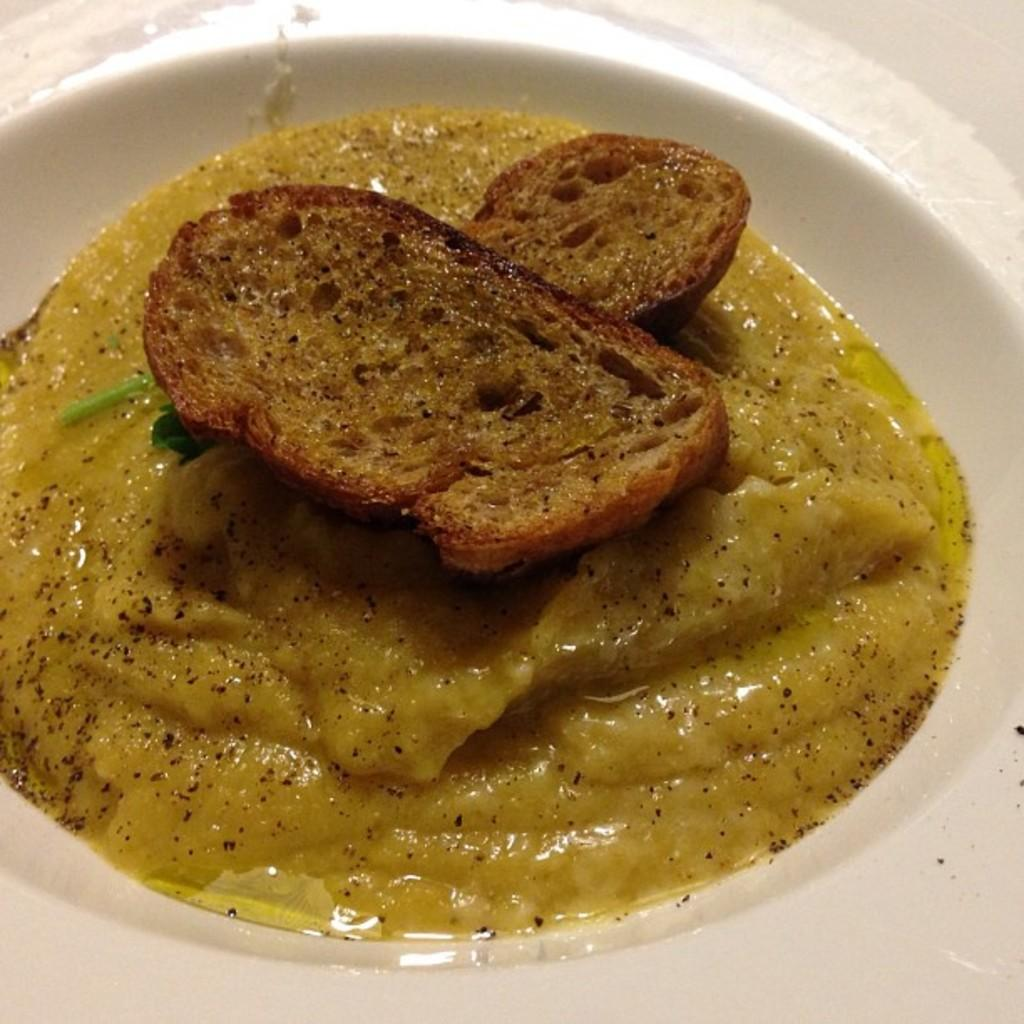What is on the plate that is visible in the image? There are food items on a plate. What is the color of the plate? The plate is white in color. How many lips can be seen on the plate in the image? There are no lips present on the plate in the image. What type of drop can be seen falling onto the plate in the image? There is no drop falling onto the plate in the image. 